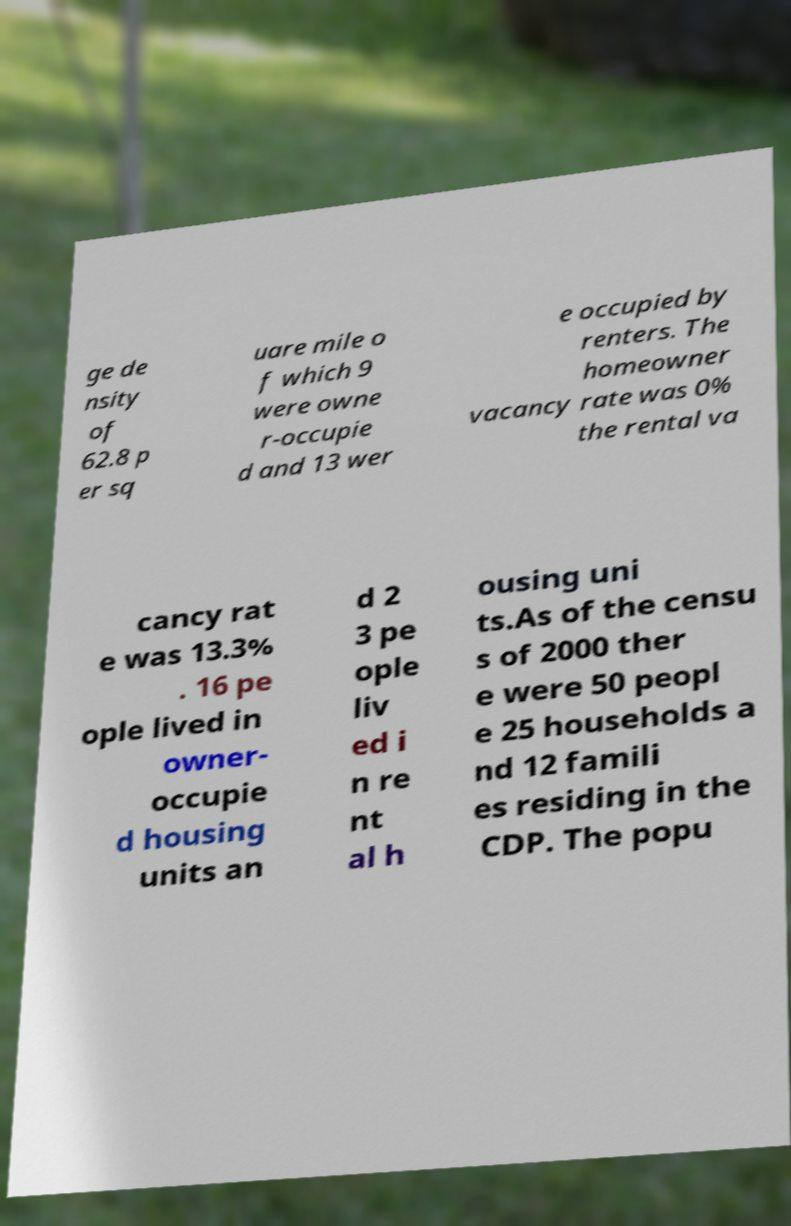Can you accurately transcribe the text from the provided image for me? ge de nsity of 62.8 p er sq uare mile o f which 9 were owne r-occupie d and 13 wer e occupied by renters. The homeowner vacancy rate was 0% the rental va cancy rat e was 13.3% . 16 pe ople lived in owner- occupie d housing units an d 2 3 pe ople liv ed i n re nt al h ousing uni ts.As of the censu s of 2000 ther e were 50 peopl e 25 households a nd 12 famili es residing in the CDP. The popu 